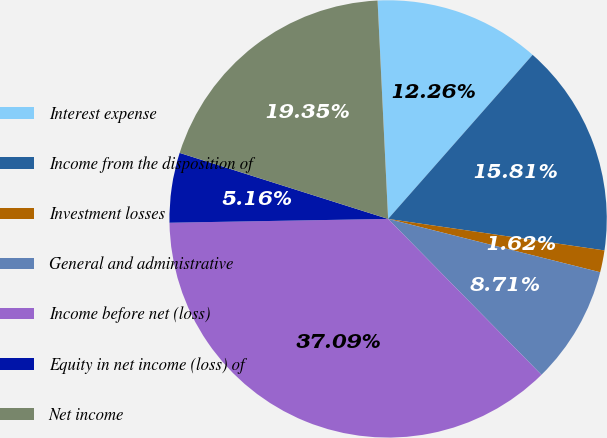Convert chart to OTSL. <chart><loc_0><loc_0><loc_500><loc_500><pie_chart><fcel>Interest expense<fcel>Income from the disposition of<fcel>Investment losses<fcel>General and administrative<fcel>Income before net (loss)<fcel>Equity in net income (loss) of<fcel>Net income<nl><fcel>12.26%<fcel>15.81%<fcel>1.62%<fcel>8.71%<fcel>37.09%<fcel>5.16%<fcel>19.35%<nl></chart> 